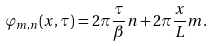<formula> <loc_0><loc_0><loc_500><loc_500>\varphi _ { m , n } ( x , \tau ) = 2 \pi \frac { \tau } { \beta } n + 2 \pi \frac { x } { L } m .</formula> 